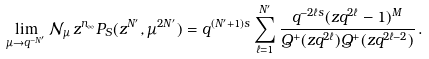Convert formula to latex. <formula><loc_0><loc_0><loc_500><loc_500>\lim _ { \mu \rightarrow q ^ { - N ^ { \prime } } } \mathcal { N } _ { \mu } \, z ^ { n _ { \infty } } P _ { S } ( z ^ { N ^ { \prime } } , \mu ^ { 2 N ^ { \prime } } ) = q ^ { ( N ^ { \prime } + 1 ) s } \sum _ { \ell = 1 } ^ { N ^ { \prime } } \frac { q ^ { - 2 \ell s } ( z q ^ { 2 \ell } - 1 ) ^ { M } } { Q ^ { + } ( z q ^ { 2 \ell } ) Q ^ { + } ( z q ^ { 2 \ell - 2 } ) } \, .</formula> 